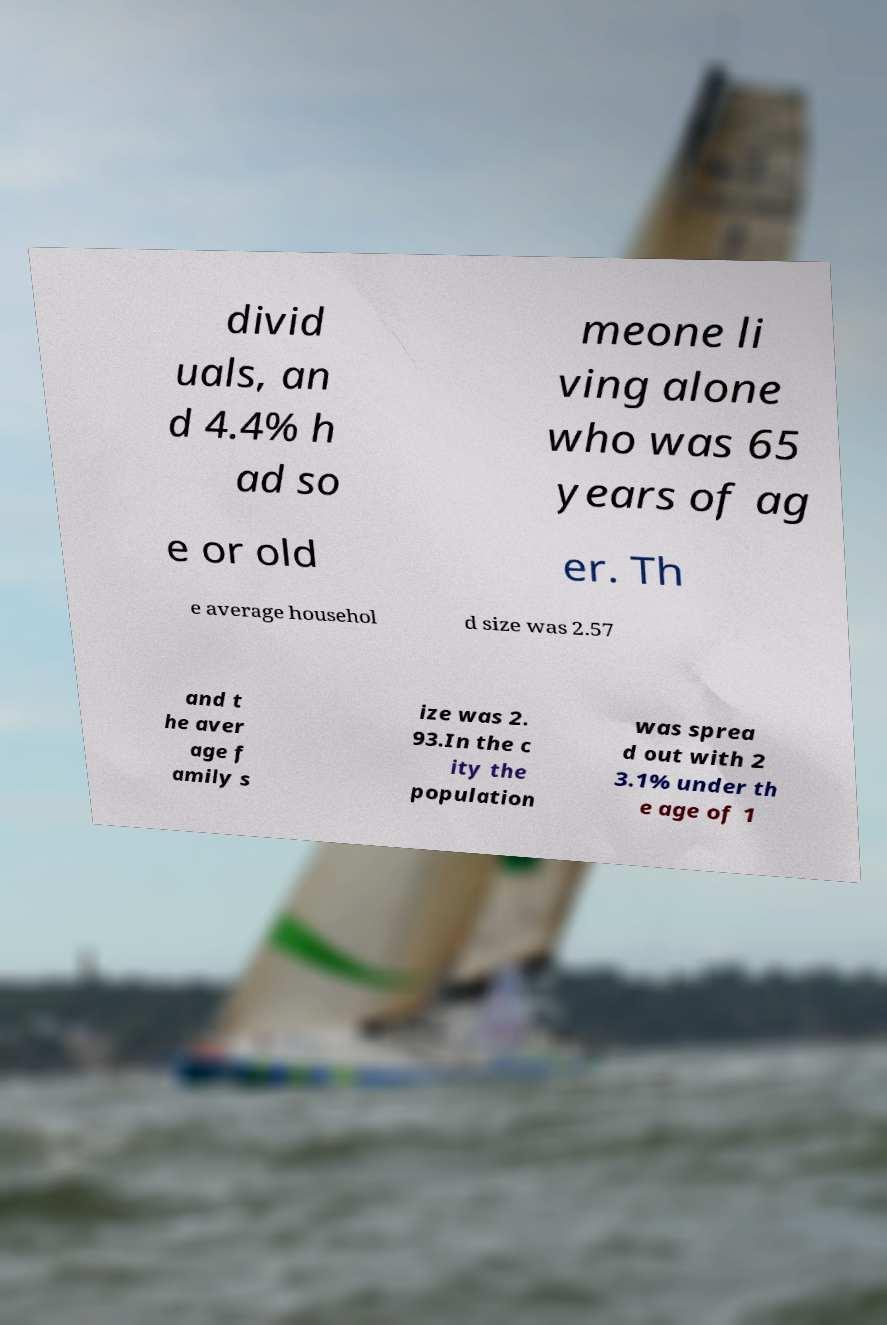I need the written content from this picture converted into text. Can you do that? divid uals, an d 4.4% h ad so meone li ving alone who was 65 years of ag e or old er. Th e average househol d size was 2.57 and t he aver age f amily s ize was 2. 93.In the c ity the population was sprea d out with 2 3.1% under th e age of 1 